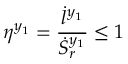Convert formula to latex. <formula><loc_0><loc_0><loc_500><loc_500>\eta ^ { y _ { 1 } } = \frac { \dot { l } ^ { y _ { 1 } } } { \dot { S } _ { r } ^ { y _ { 1 } } } \leq 1</formula> 